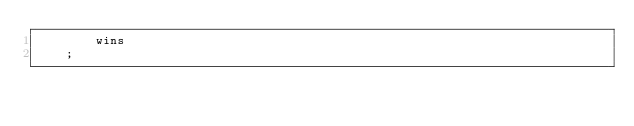<code> <loc_0><loc_0><loc_500><loc_500><_SQL_>        wins
    ;
</code> 